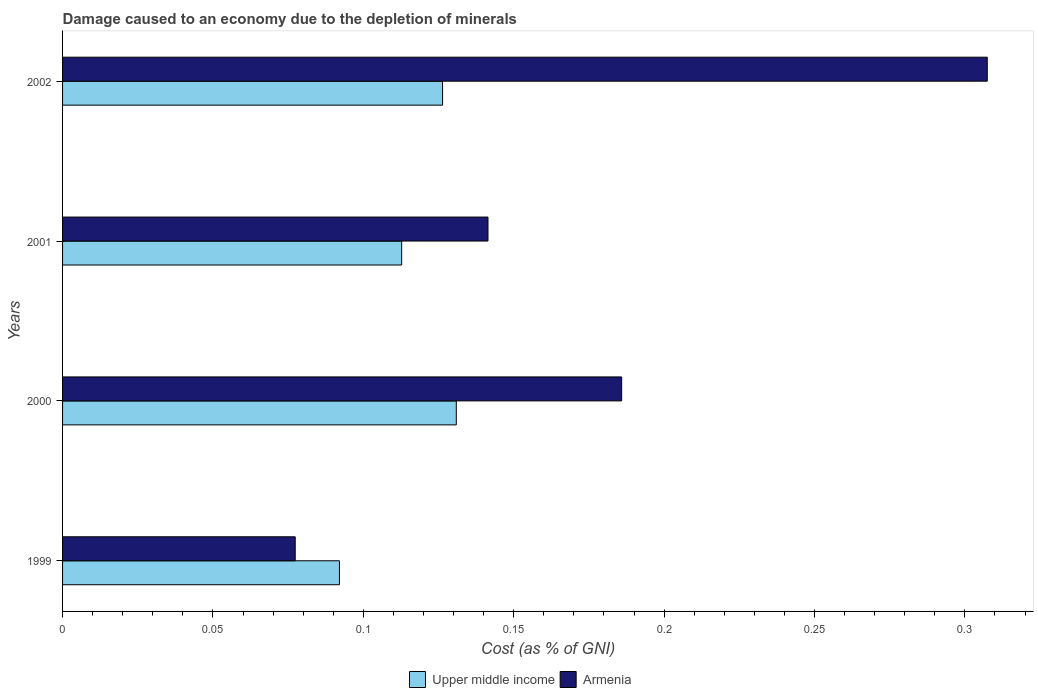How many different coloured bars are there?
Your answer should be very brief. 2. Are the number of bars per tick equal to the number of legend labels?
Provide a succinct answer. Yes. Are the number of bars on each tick of the Y-axis equal?
Make the answer very short. Yes. How many bars are there on the 1st tick from the top?
Make the answer very short. 2. How many bars are there on the 3rd tick from the bottom?
Provide a succinct answer. 2. What is the cost of damage caused due to the depletion of minerals in Upper middle income in 2001?
Offer a terse response. 0.11. Across all years, what is the maximum cost of damage caused due to the depletion of minerals in Armenia?
Offer a terse response. 0.31. Across all years, what is the minimum cost of damage caused due to the depletion of minerals in Armenia?
Offer a terse response. 0.08. In which year was the cost of damage caused due to the depletion of minerals in Upper middle income maximum?
Your answer should be very brief. 2000. What is the total cost of damage caused due to the depletion of minerals in Upper middle income in the graph?
Your response must be concise. 0.46. What is the difference between the cost of damage caused due to the depletion of minerals in Upper middle income in 1999 and that in 2000?
Your answer should be very brief. -0.04. What is the difference between the cost of damage caused due to the depletion of minerals in Upper middle income in 1999 and the cost of damage caused due to the depletion of minerals in Armenia in 2002?
Make the answer very short. -0.22. What is the average cost of damage caused due to the depletion of minerals in Armenia per year?
Ensure brevity in your answer.  0.18. In the year 2001, what is the difference between the cost of damage caused due to the depletion of minerals in Upper middle income and cost of damage caused due to the depletion of minerals in Armenia?
Make the answer very short. -0.03. What is the ratio of the cost of damage caused due to the depletion of minerals in Upper middle income in 2000 to that in 2002?
Ensure brevity in your answer.  1.04. Is the difference between the cost of damage caused due to the depletion of minerals in Upper middle income in 1999 and 2001 greater than the difference between the cost of damage caused due to the depletion of minerals in Armenia in 1999 and 2001?
Your answer should be very brief. Yes. What is the difference between the highest and the second highest cost of damage caused due to the depletion of minerals in Armenia?
Provide a short and direct response. 0.12. What is the difference between the highest and the lowest cost of damage caused due to the depletion of minerals in Armenia?
Keep it short and to the point. 0.23. In how many years, is the cost of damage caused due to the depletion of minerals in Armenia greater than the average cost of damage caused due to the depletion of minerals in Armenia taken over all years?
Your response must be concise. 2. What does the 2nd bar from the top in 1999 represents?
Offer a very short reply. Upper middle income. What does the 1st bar from the bottom in 1999 represents?
Ensure brevity in your answer.  Upper middle income. How many bars are there?
Provide a short and direct response. 8. Are all the bars in the graph horizontal?
Provide a succinct answer. Yes. What is the difference between two consecutive major ticks on the X-axis?
Provide a short and direct response. 0.05. Does the graph contain any zero values?
Provide a short and direct response. No. Does the graph contain grids?
Keep it short and to the point. No. How are the legend labels stacked?
Give a very brief answer. Horizontal. What is the title of the graph?
Provide a succinct answer. Damage caused to an economy due to the depletion of minerals. What is the label or title of the X-axis?
Your response must be concise. Cost (as % of GNI). What is the Cost (as % of GNI) of Upper middle income in 1999?
Offer a very short reply. 0.09. What is the Cost (as % of GNI) in Armenia in 1999?
Your answer should be very brief. 0.08. What is the Cost (as % of GNI) of Upper middle income in 2000?
Offer a terse response. 0.13. What is the Cost (as % of GNI) in Armenia in 2000?
Ensure brevity in your answer.  0.19. What is the Cost (as % of GNI) of Upper middle income in 2001?
Make the answer very short. 0.11. What is the Cost (as % of GNI) in Armenia in 2001?
Offer a very short reply. 0.14. What is the Cost (as % of GNI) of Upper middle income in 2002?
Ensure brevity in your answer.  0.13. What is the Cost (as % of GNI) of Armenia in 2002?
Give a very brief answer. 0.31. Across all years, what is the maximum Cost (as % of GNI) of Upper middle income?
Provide a short and direct response. 0.13. Across all years, what is the maximum Cost (as % of GNI) of Armenia?
Provide a succinct answer. 0.31. Across all years, what is the minimum Cost (as % of GNI) of Upper middle income?
Offer a very short reply. 0.09. Across all years, what is the minimum Cost (as % of GNI) in Armenia?
Offer a terse response. 0.08. What is the total Cost (as % of GNI) in Upper middle income in the graph?
Make the answer very short. 0.46. What is the total Cost (as % of GNI) of Armenia in the graph?
Your answer should be very brief. 0.71. What is the difference between the Cost (as % of GNI) in Upper middle income in 1999 and that in 2000?
Provide a short and direct response. -0.04. What is the difference between the Cost (as % of GNI) in Armenia in 1999 and that in 2000?
Provide a short and direct response. -0.11. What is the difference between the Cost (as % of GNI) of Upper middle income in 1999 and that in 2001?
Provide a succinct answer. -0.02. What is the difference between the Cost (as % of GNI) of Armenia in 1999 and that in 2001?
Your answer should be compact. -0.06. What is the difference between the Cost (as % of GNI) in Upper middle income in 1999 and that in 2002?
Keep it short and to the point. -0.03. What is the difference between the Cost (as % of GNI) in Armenia in 1999 and that in 2002?
Offer a terse response. -0.23. What is the difference between the Cost (as % of GNI) in Upper middle income in 2000 and that in 2001?
Make the answer very short. 0.02. What is the difference between the Cost (as % of GNI) of Armenia in 2000 and that in 2001?
Give a very brief answer. 0.04. What is the difference between the Cost (as % of GNI) in Upper middle income in 2000 and that in 2002?
Ensure brevity in your answer.  0. What is the difference between the Cost (as % of GNI) of Armenia in 2000 and that in 2002?
Make the answer very short. -0.12. What is the difference between the Cost (as % of GNI) in Upper middle income in 2001 and that in 2002?
Offer a terse response. -0.01. What is the difference between the Cost (as % of GNI) of Armenia in 2001 and that in 2002?
Your answer should be very brief. -0.17. What is the difference between the Cost (as % of GNI) of Upper middle income in 1999 and the Cost (as % of GNI) of Armenia in 2000?
Make the answer very short. -0.09. What is the difference between the Cost (as % of GNI) of Upper middle income in 1999 and the Cost (as % of GNI) of Armenia in 2001?
Keep it short and to the point. -0.05. What is the difference between the Cost (as % of GNI) of Upper middle income in 1999 and the Cost (as % of GNI) of Armenia in 2002?
Your answer should be very brief. -0.22. What is the difference between the Cost (as % of GNI) of Upper middle income in 2000 and the Cost (as % of GNI) of Armenia in 2001?
Your answer should be compact. -0.01. What is the difference between the Cost (as % of GNI) of Upper middle income in 2000 and the Cost (as % of GNI) of Armenia in 2002?
Provide a succinct answer. -0.18. What is the difference between the Cost (as % of GNI) in Upper middle income in 2001 and the Cost (as % of GNI) in Armenia in 2002?
Offer a terse response. -0.19. What is the average Cost (as % of GNI) of Upper middle income per year?
Offer a very short reply. 0.12. What is the average Cost (as % of GNI) in Armenia per year?
Provide a succinct answer. 0.18. In the year 1999, what is the difference between the Cost (as % of GNI) of Upper middle income and Cost (as % of GNI) of Armenia?
Your answer should be very brief. 0.01. In the year 2000, what is the difference between the Cost (as % of GNI) in Upper middle income and Cost (as % of GNI) in Armenia?
Your answer should be very brief. -0.06. In the year 2001, what is the difference between the Cost (as % of GNI) in Upper middle income and Cost (as % of GNI) in Armenia?
Keep it short and to the point. -0.03. In the year 2002, what is the difference between the Cost (as % of GNI) in Upper middle income and Cost (as % of GNI) in Armenia?
Offer a terse response. -0.18. What is the ratio of the Cost (as % of GNI) in Upper middle income in 1999 to that in 2000?
Your answer should be very brief. 0.7. What is the ratio of the Cost (as % of GNI) in Armenia in 1999 to that in 2000?
Your response must be concise. 0.42. What is the ratio of the Cost (as % of GNI) of Upper middle income in 1999 to that in 2001?
Offer a terse response. 0.82. What is the ratio of the Cost (as % of GNI) of Armenia in 1999 to that in 2001?
Provide a short and direct response. 0.55. What is the ratio of the Cost (as % of GNI) in Upper middle income in 1999 to that in 2002?
Your answer should be compact. 0.73. What is the ratio of the Cost (as % of GNI) in Armenia in 1999 to that in 2002?
Keep it short and to the point. 0.25. What is the ratio of the Cost (as % of GNI) of Upper middle income in 2000 to that in 2001?
Your answer should be compact. 1.16. What is the ratio of the Cost (as % of GNI) of Armenia in 2000 to that in 2001?
Offer a very short reply. 1.31. What is the ratio of the Cost (as % of GNI) in Upper middle income in 2000 to that in 2002?
Make the answer very short. 1.04. What is the ratio of the Cost (as % of GNI) of Armenia in 2000 to that in 2002?
Your response must be concise. 0.6. What is the ratio of the Cost (as % of GNI) in Upper middle income in 2001 to that in 2002?
Your answer should be compact. 0.89. What is the ratio of the Cost (as % of GNI) in Armenia in 2001 to that in 2002?
Keep it short and to the point. 0.46. What is the difference between the highest and the second highest Cost (as % of GNI) of Upper middle income?
Offer a terse response. 0. What is the difference between the highest and the second highest Cost (as % of GNI) of Armenia?
Offer a very short reply. 0.12. What is the difference between the highest and the lowest Cost (as % of GNI) in Upper middle income?
Your answer should be compact. 0.04. What is the difference between the highest and the lowest Cost (as % of GNI) of Armenia?
Keep it short and to the point. 0.23. 